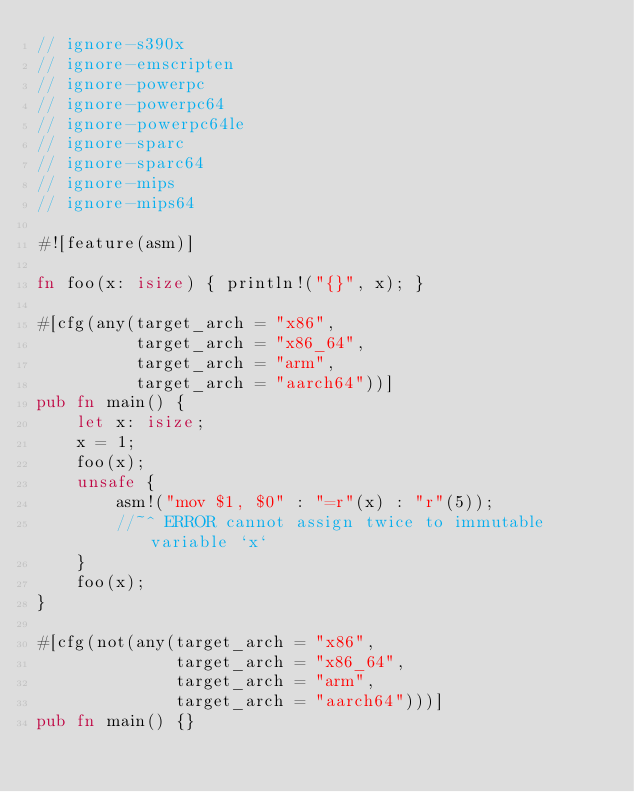<code> <loc_0><loc_0><loc_500><loc_500><_Rust_>// ignore-s390x
// ignore-emscripten
// ignore-powerpc
// ignore-powerpc64
// ignore-powerpc64le
// ignore-sparc
// ignore-sparc64
// ignore-mips
// ignore-mips64

#![feature(asm)]

fn foo(x: isize) { println!("{}", x); }

#[cfg(any(target_arch = "x86",
          target_arch = "x86_64",
          target_arch = "arm",
          target_arch = "aarch64"))]
pub fn main() {
    let x: isize;
    x = 1;
    foo(x);
    unsafe {
        asm!("mov $1, $0" : "=r"(x) : "r"(5));
        //~^ ERROR cannot assign twice to immutable variable `x`
    }
    foo(x);
}

#[cfg(not(any(target_arch = "x86",
              target_arch = "x86_64",
              target_arch = "arm",
              target_arch = "aarch64")))]
pub fn main() {}
</code> 